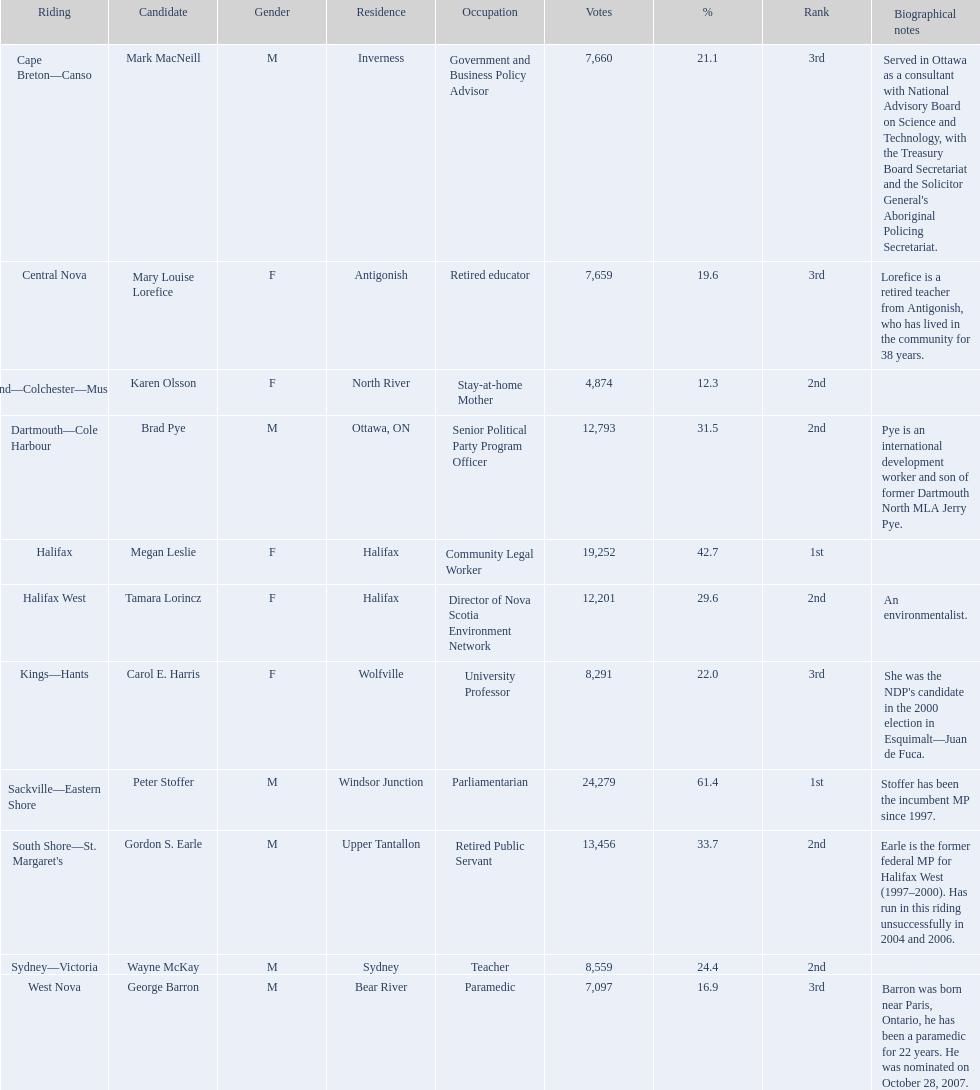Who were the 2008 new democratic party nominees? Mark MacNeill, Mary Louise Lorefice, Karen Olsson, Brad Pye, Megan Leslie, Tamara Lorincz, Carol E. Harris, Peter Stoffer, Gordon S. Earle, Wayne McKay, George Barron. Who received the second highest number of votes? Megan Leslie, Peter Stoffer. How many votes did she get? 19,252. 